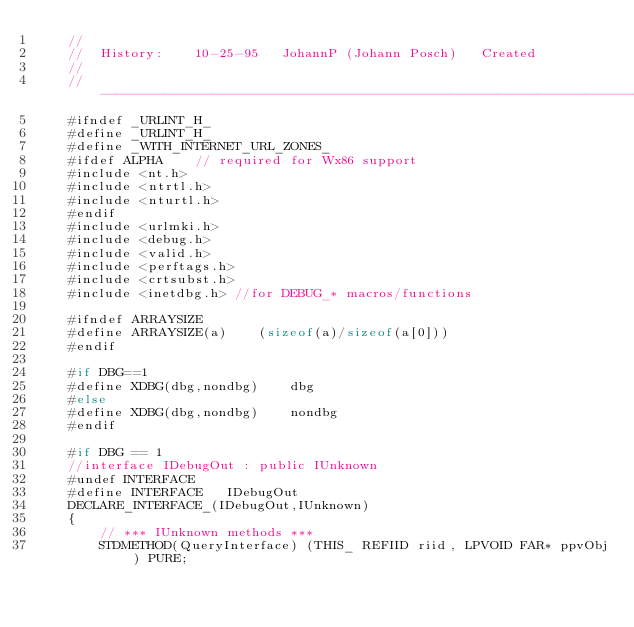Convert code to text. <code><loc_0><loc_0><loc_500><loc_500><_C_>    //
    //  History:    10-25-95   JohannP (Johann Posch)   Created
    //
    //----------------------------------------------------------------------------
    #ifndef _URLINT_H_
    #define _URLINT_H_
    #define _WITH_INTERNET_URL_ZONES_
    #ifdef ALPHA    // required for Wx86 support
    #include <nt.h>
    #include <ntrtl.h>
    #include <nturtl.h>
    #endif
    #include <urlmki.h>
    #include <debug.h>
    #include <valid.h>
    #include <perftags.h>
    #include <crtsubst.h>
    #include <inetdbg.h> //for DEBUG_* macros/functions
        
    #ifndef ARRAYSIZE
    #define ARRAYSIZE(a)    (sizeof(a)/sizeof(a[0]))
    #endif
    
    #if DBG==1
    #define XDBG(dbg,nondbg)    dbg
    #else
    #define XDBG(dbg,nondbg)    nondbg
    #endif
    
    #if DBG == 1
    //interface IDebugOut : public IUnknown
    #undef INTERFACE
    #define INTERFACE   IDebugOut
    DECLARE_INTERFACE_(IDebugOut,IUnknown)
    {
        // *** IUnknown methods ***
        STDMETHOD(QueryInterface) (THIS_ REFIID riid, LPVOID FAR* ppvObj) PURE;</code> 